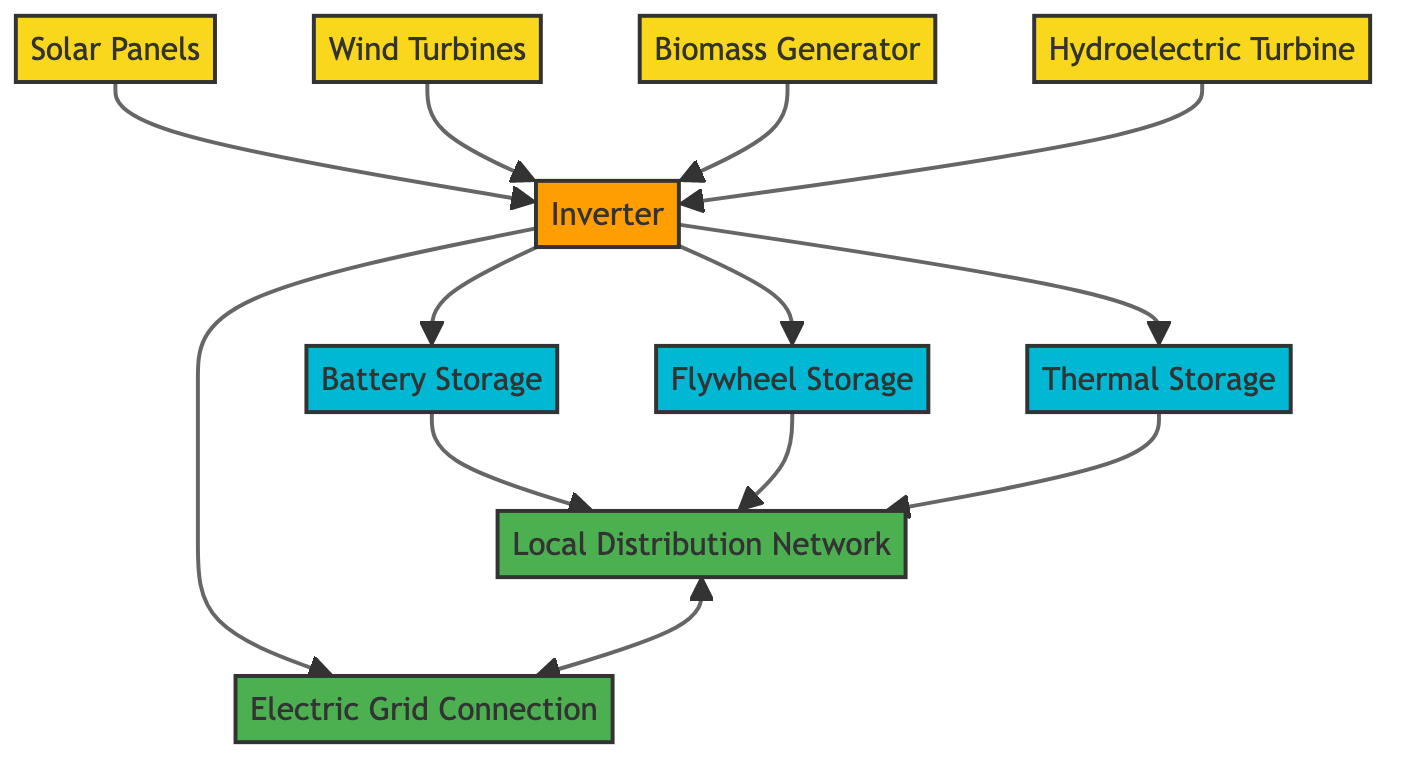What are the sources of energy in the system? The diagram lists the following energy sources: Solar Panels, Wind Turbines, Biomass Generator, and Hydroelectric Turbine.
Answer: Solar Panels, Wind Turbines, Biomass Generator, Hydroelectric Turbine How many storage types are there? The diagram identifies three types of storage: Battery Storage, Flywheel Storage, and Thermal Storage. Counting these gives a total of three storage types.
Answer: 3 Which node receives electricity from the Wind Turbines? According to the diagram, the Wind Turbines send electricity to the Inverter, which is the node that receives it.
Answer: Inverter What is the purpose of the Inverter in the system? The Inverter's role is to convert DC electricity from renewable sources into AC electricity, making it essential for the system's overall function.
Answer: Convert DC to AC How does electricity from the Battery Storage reach local consumers? Electricity stored in Battery Storage is distributed to the Local Distribution Network, connecting it directly to local consumers.
Answer: Local Distribution Network Which storage type uses rotational kinetic energy? The diagram indicates that Flywheel Storage operates by using rotational kinetic energy, specifically designed for energy storage.
Answer: Flywheel Storage How many connections are there from the Inverter to storage components? The Inverter connects to three storage components: Battery Storage, Flywheel Storage, and Thermal Storage, making a total of three connections.
Answer: 3 Which component distributes surplus electricity to the electric grid? The diagram shows that surplus electricity is sent to the Electric Grid Connection, which is responsible for distributing it to the grid.
Answer: Electric Grid Connection What type of connection exists between Local Distribution Network and Electric Grid Connection? The diagram specifies a bidirectional connection between the Local Distribution Network and the Electric Grid Connection, allowing energy to flow both ways.
Answer: Bidirectional connection 